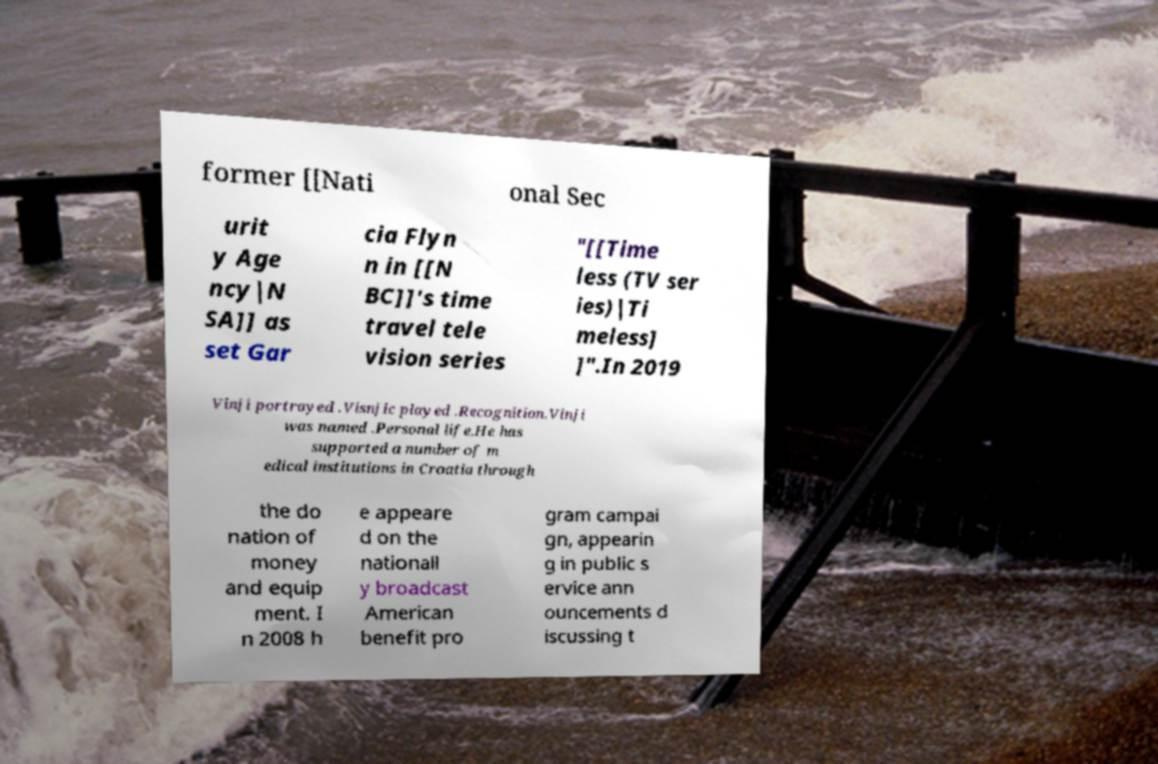Please read and relay the text visible in this image. What does it say? former [[Nati onal Sec urit y Age ncy|N SA]] as set Gar cia Flyn n in [[N BC]]'s time travel tele vision series "[[Time less (TV ser ies)|Ti meless] ]".In 2019 Vinji portrayed .Visnjic played .Recognition.Vinji was named .Personal life.He has supported a number of m edical institutions in Croatia through the do nation of money and equip ment. I n 2008 h e appeare d on the nationall y broadcast American benefit pro gram campai gn, appearin g in public s ervice ann ouncements d iscussing t 